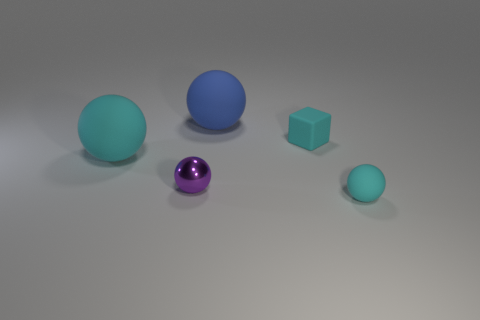Add 2 tiny rubber cubes. How many objects exist? 7 Subtract all blocks. How many objects are left? 4 Add 3 blue objects. How many blue objects are left? 4 Add 4 rubber spheres. How many rubber spheres exist? 7 Subtract 0 gray blocks. How many objects are left? 5 Subtract all big green rubber objects. Subtract all cyan spheres. How many objects are left? 3 